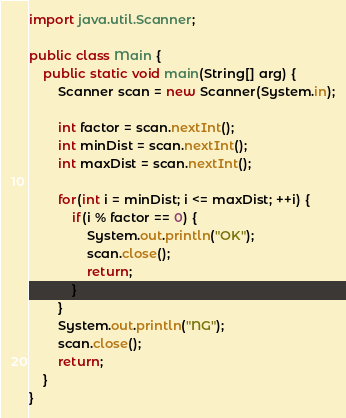Convert code to text. <code><loc_0><loc_0><loc_500><loc_500><_Java_>import java.util.Scanner;

public class Main {
    public static void main(String[] arg) {
        Scanner scan = new Scanner(System.in);

        int factor = scan.nextInt();
        int minDist = scan.nextInt();
        int maxDist = scan.nextInt();

        for(int i = minDist; i <= maxDist; ++i) {
            if(i % factor == 0) {
                System.out.println("OK");
                scan.close();
                return;
            }
        }
        System.out.println("NG");
        scan.close();
        return;
    }
}</code> 